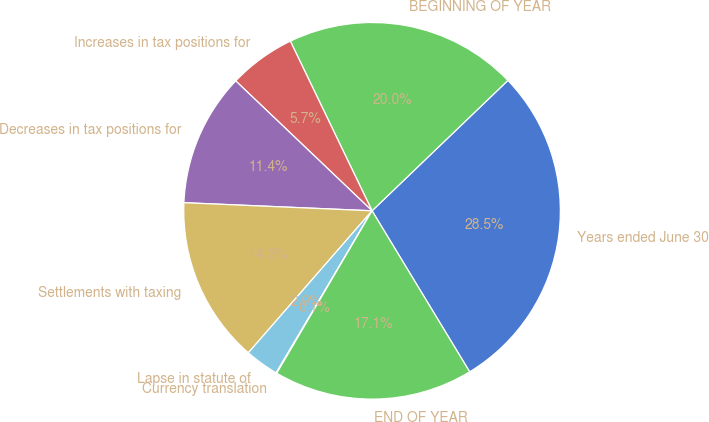Convert chart to OTSL. <chart><loc_0><loc_0><loc_500><loc_500><pie_chart><fcel>Years ended June 30<fcel>BEGINNING OF YEAR<fcel>Increases in tax positions for<fcel>Decreases in tax positions for<fcel>Settlements with taxing<fcel>Lapse in statute of<fcel>Currency translation<fcel>END OF YEAR<nl><fcel>28.5%<fcel>19.97%<fcel>5.74%<fcel>11.43%<fcel>14.28%<fcel>2.9%<fcel>0.06%<fcel>17.12%<nl></chart> 